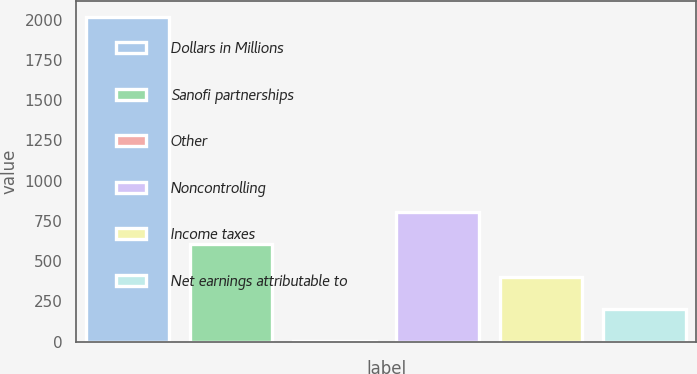<chart> <loc_0><loc_0><loc_500><loc_500><bar_chart><fcel>Dollars in Millions<fcel>Sanofi partnerships<fcel>Other<fcel>Noncontrolling<fcel>Income taxes<fcel>Net earnings attributable to<nl><fcel>2013<fcel>604.6<fcel>1<fcel>805.8<fcel>403.4<fcel>202.2<nl></chart> 